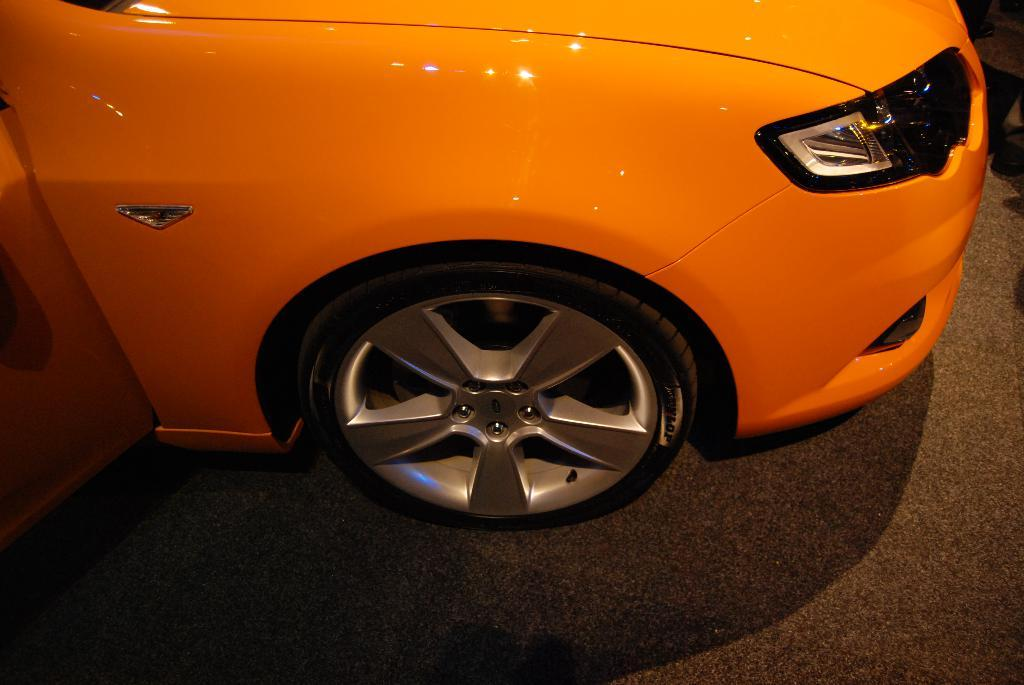What is the main subject in the image? There is a vehicle in the image. What type of account is associated with the vehicle in the image? There is no information about any account associated with the vehicle in the image. What type of suit is the vehicle wearing in the image? Vehicles do not wear suits, as they are inanimate objects. 